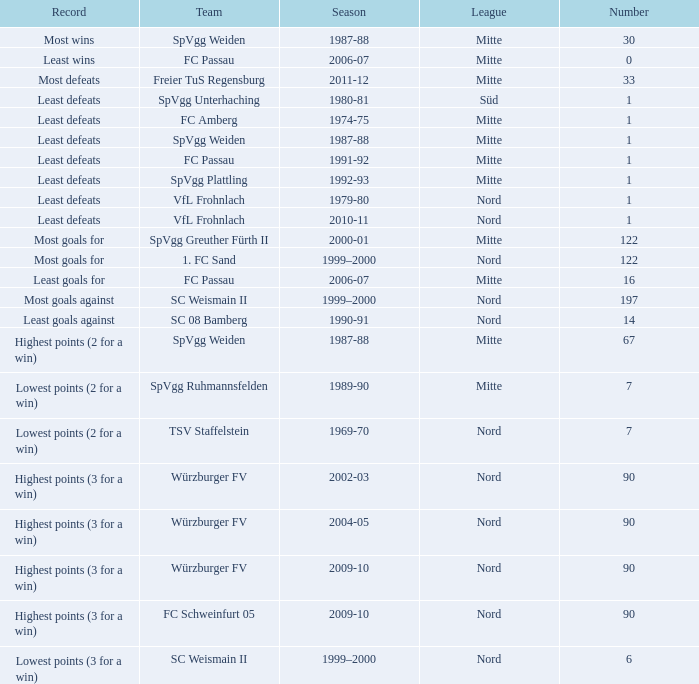What season has a number less than 90, Mitte as the league and spvgg ruhmannsfelden as the team? 1989-90. 